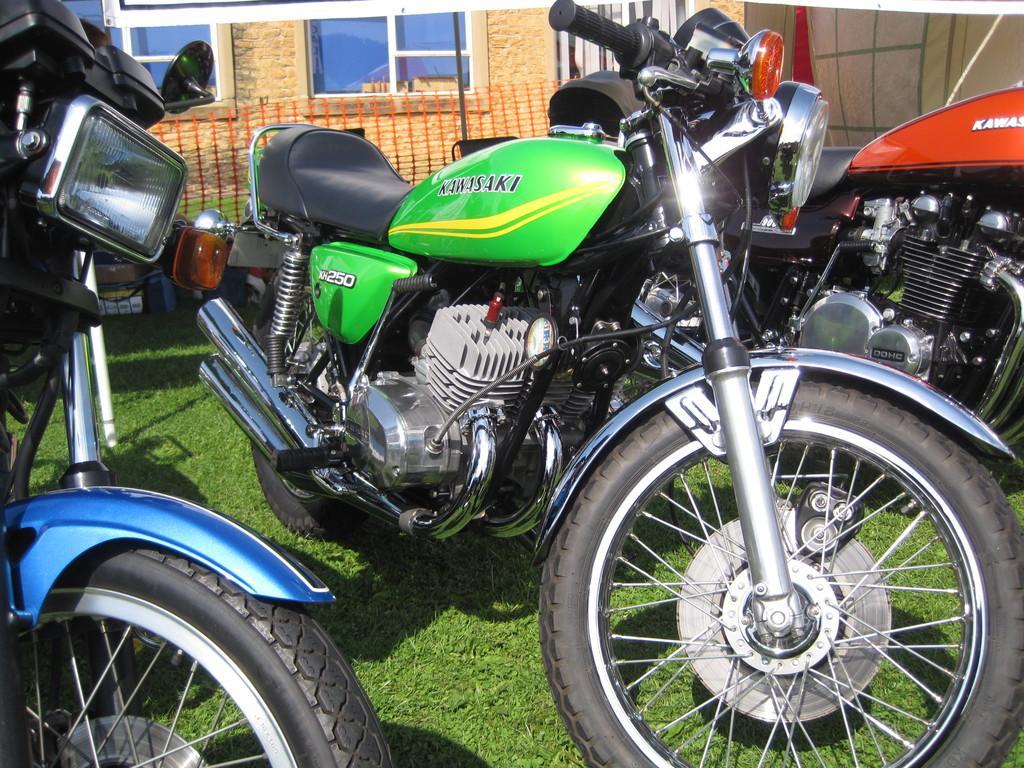In one or two sentences, can you explain what this image depicts? In this picture we can see three bikes parked, at the bottom there is grass, we can see a house in the background, we can see two windows here. 